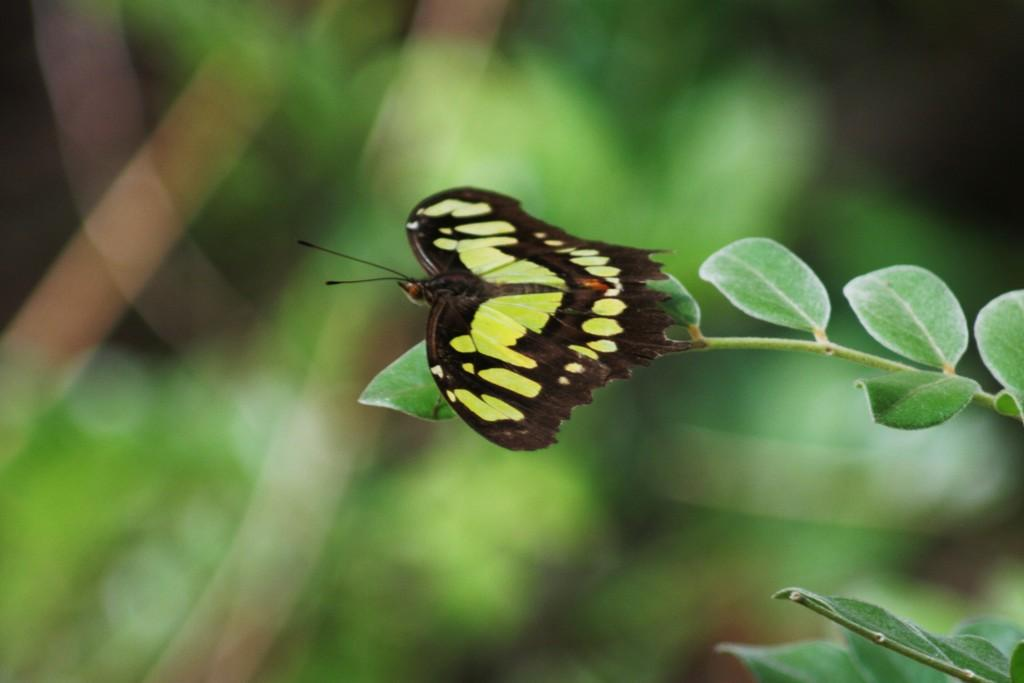What can be seen in the foreground of the picture? In the foreground of the picture, there are leaves, a stem, and a butterfly. What type of vegetation is present in the picture? There is greenery in the background of the picture. What type of rhythm can be heard coming from the oatmeal in the picture? There is no oatmeal present in the picture, so it's not possible to determine any rhythm associated with it. 